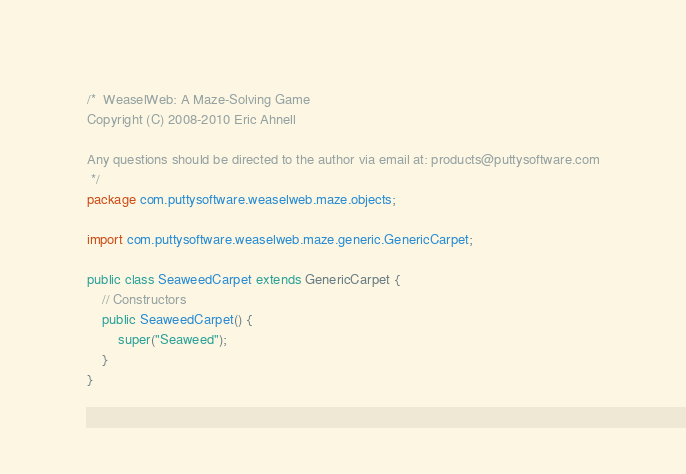Convert code to text. <code><loc_0><loc_0><loc_500><loc_500><_Java_>/*  WeaselWeb: A Maze-Solving Game
Copyright (C) 2008-2010 Eric Ahnell

Any questions should be directed to the author via email at: products@puttysoftware.com
 */
package com.puttysoftware.weaselweb.maze.objects;

import com.puttysoftware.weaselweb.maze.generic.GenericCarpet;

public class SeaweedCarpet extends GenericCarpet {
    // Constructors
    public SeaweedCarpet() {
        super("Seaweed");
    }
}</code> 